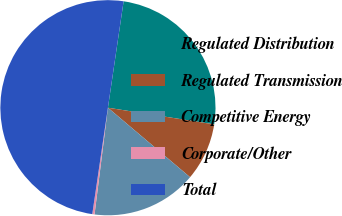Convert chart to OTSL. <chart><loc_0><loc_0><loc_500><loc_500><pie_chart><fcel>Regulated Distribution<fcel>Regulated Transmission<fcel>Competitive Energy<fcel>Corporate/Other<fcel>Total<nl><fcel>25.14%<fcel>8.7%<fcel>15.81%<fcel>0.34%<fcel>50.0%<nl></chart> 